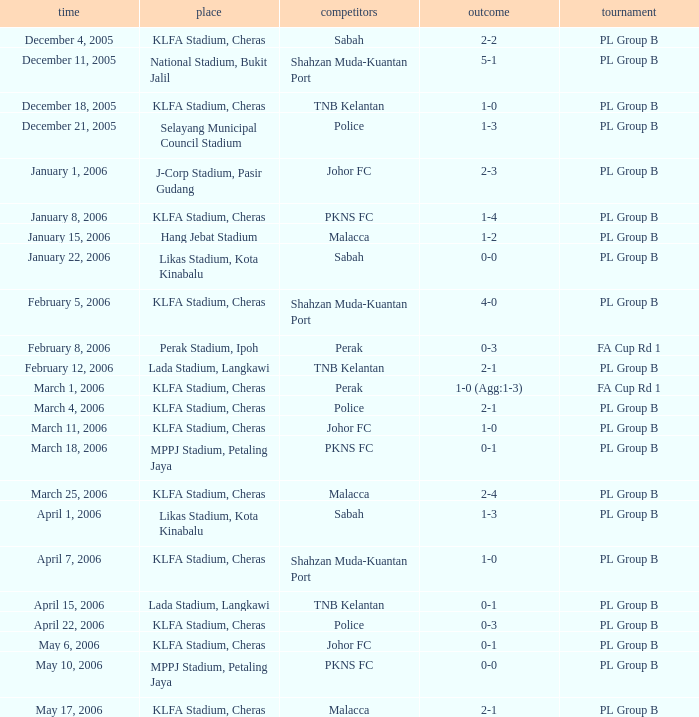Parse the table in full. {'header': ['time', 'place', 'competitors', 'outcome', 'tournament'], 'rows': [['December 4, 2005', 'KLFA Stadium, Cheras', 'Sabah', '2-2', 'PL Group B'], ['December 11, 2005', 'National Stadium, Bukit Jalil', 'Shahzan Muda-Kuantan Port', '5-1', 'PL Group B'], ['December 18, 2005', 'KLFA Stadium, Cheras', 'TNB Kelantan', '1-0', 'PL Group B'], ['December 21, 2005', 'Selayang Municipal Council Stadium', 'Police', '1-3', 'PL Group B'], ['January 1, 2006', 'J-Corp Stadium, Pasir Gudang', 'Johor FC', '2-3', 'PL Group B'], ['January 8, 2006', 'KLFA Stadium, Cheras', 'PKNS FC', '1-4', 'PL Group B'], ['January 15, 2006', 'Hang Jebat Stadium', 'Malacca', '1-2', 'PL Group B'], ['January 22, 2006', 'Likas Stadium, Kota Kinabalu', 'Sabah', '0-0', 'PL Group B'], ['February 5, 2006', 'KLFA Stadium, Cheras', 'Shahzan Muda-Kuantan Port', '4-0', 'PL Group B'], ['February 8, 2006', 'Perak Stadium, Ipoh', 'Perak', '0-3', 'FA Cup Rd 1'], ['February 12, 2006', 'Lada Stadium, Langkawi', 'TNB Kelantan', '2-1', 'PL Group B'], ['March 1, 2006', 'KLFA Stadium, Cheras', 'Perak', '1-0 (Agg:1-3)', 'FA Cup Rd 1'], ['March 4, 2006', 'KLFA Stadium, Cheras', 'Police', '2-1', 'PL Group B'], ['March 11, 2006', 'KLFA Stadium, Cheras', 'Johor FC', '1-0', 'PL Group B'], ['March 18, 2006', 'MPPJ Stadium, Petaling Jaya', 'PKNS FC', '0-1', 'PL Group B'], ['March 25, 2006', 'KLFA Stadium, Cheras', 'Malacca', '2-4', 'PL Group B'], ['April 1, 2006', 'Likas Stadium, Kota Kinabalu', 'Sabah', '1-3', 'PL Group B'], ['April 7, 2006', 'KLFA Stadium, Cheras', 'Shahzan Muda-Kuantan Port', '1-0', 'PL Group B'], ['April 15, 2006', 'Lada Stadium, Langkawi', 'TNB Kelantan', '0-1', 'PL Group B'], ['April 22, 2006', 'KLFA Stadium, Cheras', 'Police', '0-3', 'PL Group B'], ['May 6, 2006', 'KLFA Stadium, Cheras', 'Johor FC', '0-1', 'PL Group B'], ['May 10, 2006', 'MPPJ Stadium, Petaling Jaya', 'PKNS FC', '0-0', 'PL Group B'], ['May 17, 2006', 'KLFA Stadium, Cheras', 'Malacca', '2-1', 'PL Group B']]} Which Competition has a Score of 0-1, and Opponents of pkns fc? PL Group B. 